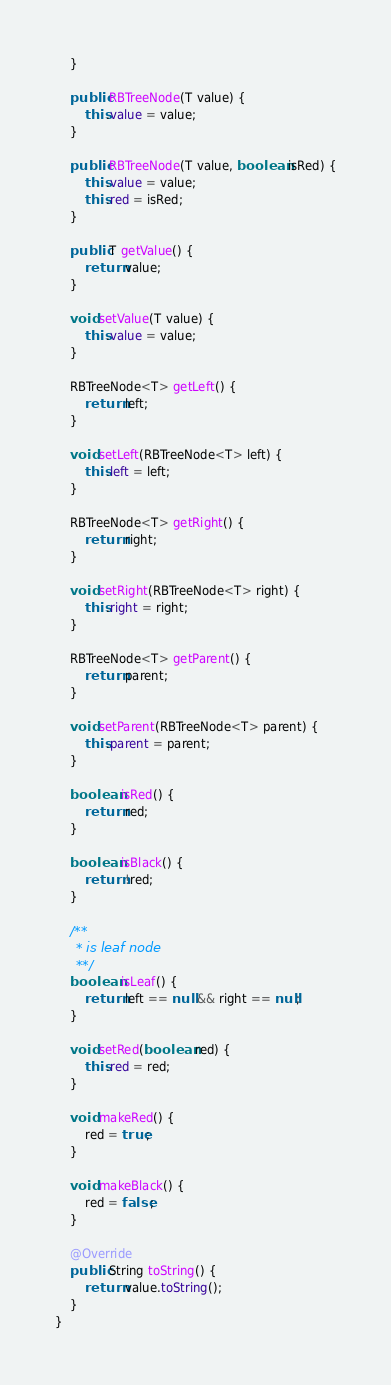<code> <loc_0><loc_0><loc_500><loc_500><_Java_>    }

    public RBTreeNode(T value) {
        this.value = value;
    }

    public RBTreeNode(T value, boolean isRed) {
        this.value = value;
        this.red = isRed;
    }

    public T getValue() {
        return value;
    }

    void setValue(T value) {
        this.value = value;
    }

    RBTreeNode<T> getLeft() {
        return left;
    }

    void setLeft(RBTreeNode<T> left) {
        this.left = left;
    }

    RBTreeNode<T> getRight() {
        return right;
    }

    void setRight(RBTreeNode<T> right) {
        this.right = right;
    }

    RBTreeNode<T> getParent() {
        return parent;
    }

    void setParent(RBTreeNode<T> parent) {
        this.parent = parent;
    }

    boolean isRed() {
        return red;
    }

    boolean isBlack() {
        return !red;
    }

    /**
     * is leaf node
     **/
    boolean isLeaf() {
        return left == null && right == null;
    }

    void setRed(boolean red) {
        this.red = red;
    }

    void makeRed() {
        red = true;
    }

    void makeBlack() {
        red = false;
    }

    @Override
    public String toString() {
        return value.toString();
    }
}

</code> 